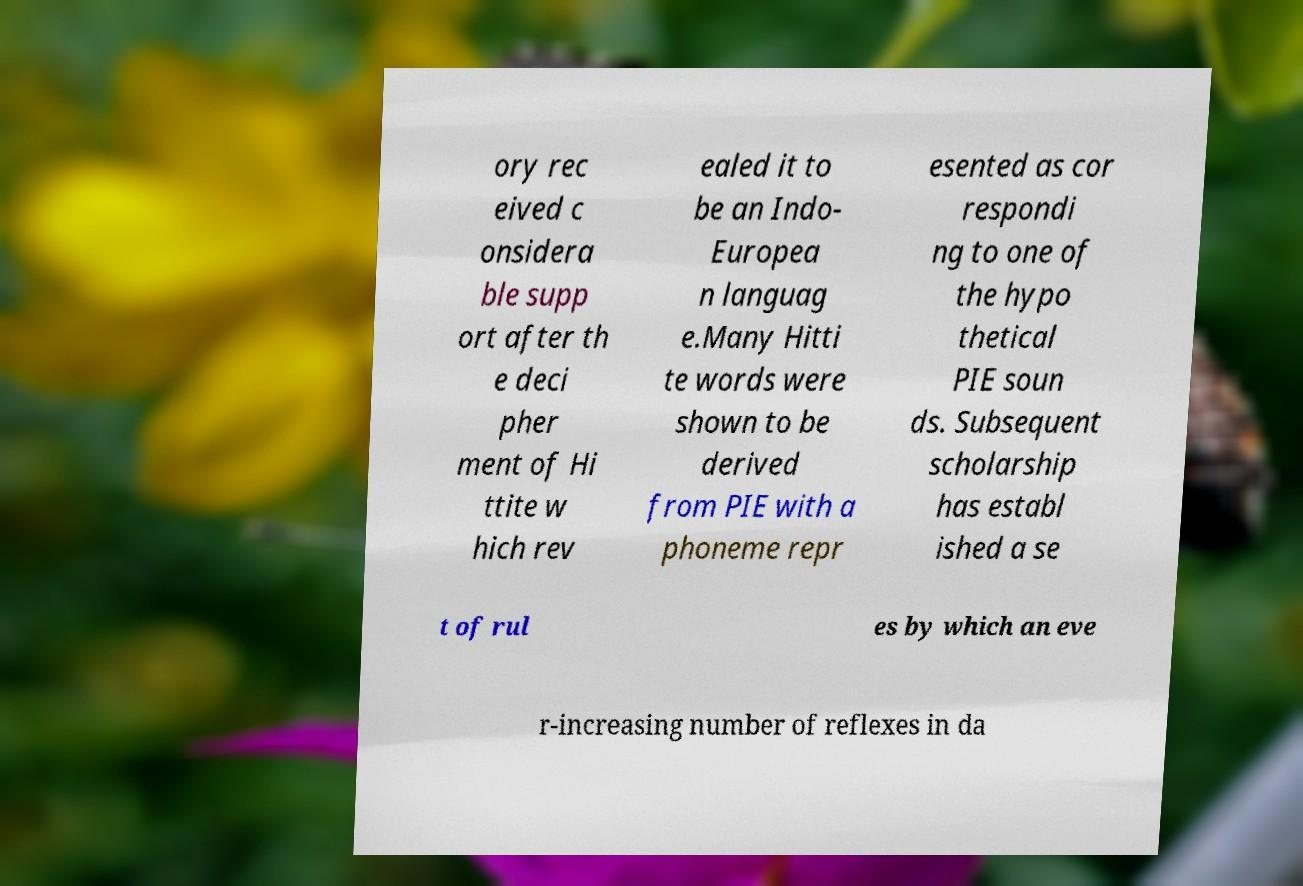There's text embedded in this image that I need extracted. Can you transcribe it verbatim? ory rec eived c onsidera ble supp ort after th e deci pher ment of Hi ttite w hich rev ealed it to be an Indo- Europea n languag e.Many Hitti te words were shown to be derived from PIE with a phoneme repr esented as cor respondi ng to one of the hypo thetical PIE soun ds. Subsequent scholarship has establ ished a se t of rul es by which an eve r-increasing number of reflexes in da 